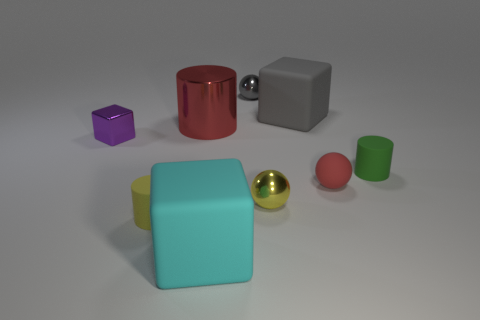Subtract all small cylinders. How many cylinders are left? 1 Add 1 small green metal balls. How many objects exist? 10 Subtract 1 balls. How many balls are left? 2 Subtract all gray cubes. How many cubes are left? 2 Subtract 0 purple balls. How many objects are left? 9 Subtract all cylinders. How many objects are left? 6 Subtract all purple cylinders. Subtract all yellow balls. How many cylinders are left? 3 Subtract all big yellow cubes. Subtract all tiny gray metallic balls. How many objects are left? 8 Add 2 large red metallic cylinders. How many large red metallic cylinders are left? 3 Add 3 rubber blocks. How many rubber blocks exist? 5 